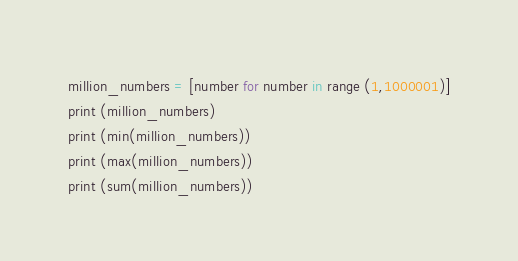<code> <loc_0><loc_0><loc_500><loc_500><_Python_>million_numbers = [number for number in range (1,1000001)]
print (million_numbers)
print (min(million_numbers))
print (max(million_numbers))
print (sum(million_numbers))</code> 